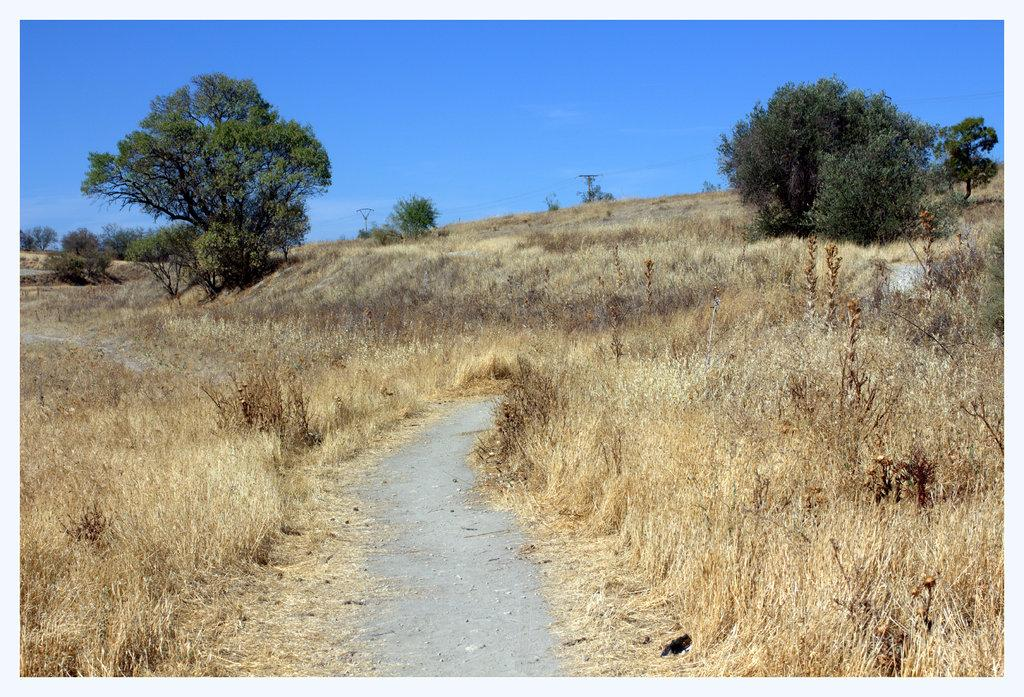What type of vegetation can be seen in the image? There is dried grass in the image. What kind of path is present in the image? There is a walkway in the image. What other natural elements are visible in the image? There are trees in the image. What man-made structure can be seen in the image? There is an electric pole in the image. What is visible at the top of the image? The sky is visible at the top of the image. What type of current is flowing through the electric pole in the image? There is no indication of any current flowing through the electric pole in the image. How does the dried grass care for the trees in the image? The dried grass does not care for the trees in the image; it is simply a type of vegetation present. 